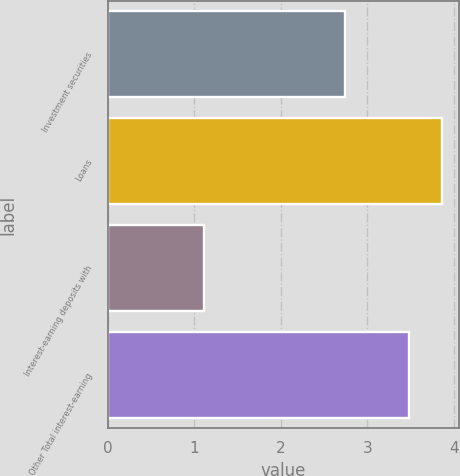Convert chart to OTSL. <chart><loc_0><loc_0><loc_500><loc_500><bar_chart><fcel>Investment securities<fcel>Loans<fcel>Interest-earning deposits with<fcel>Other Total interest-earning<nl><fcel>2.74<fcel>3.86<fcel>1.11<fcel>3.48<nl></chart> 